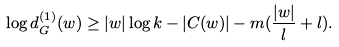Convert formula to latex. <formula><loc_0><loc_0><loc_500><loc_500>\log d _ { G } ^ { ( 1 ) } ( w ) \geq | w | \log k - | C ( w ) | - m ( \frac { | w | } { l } + l ) .</formula> 